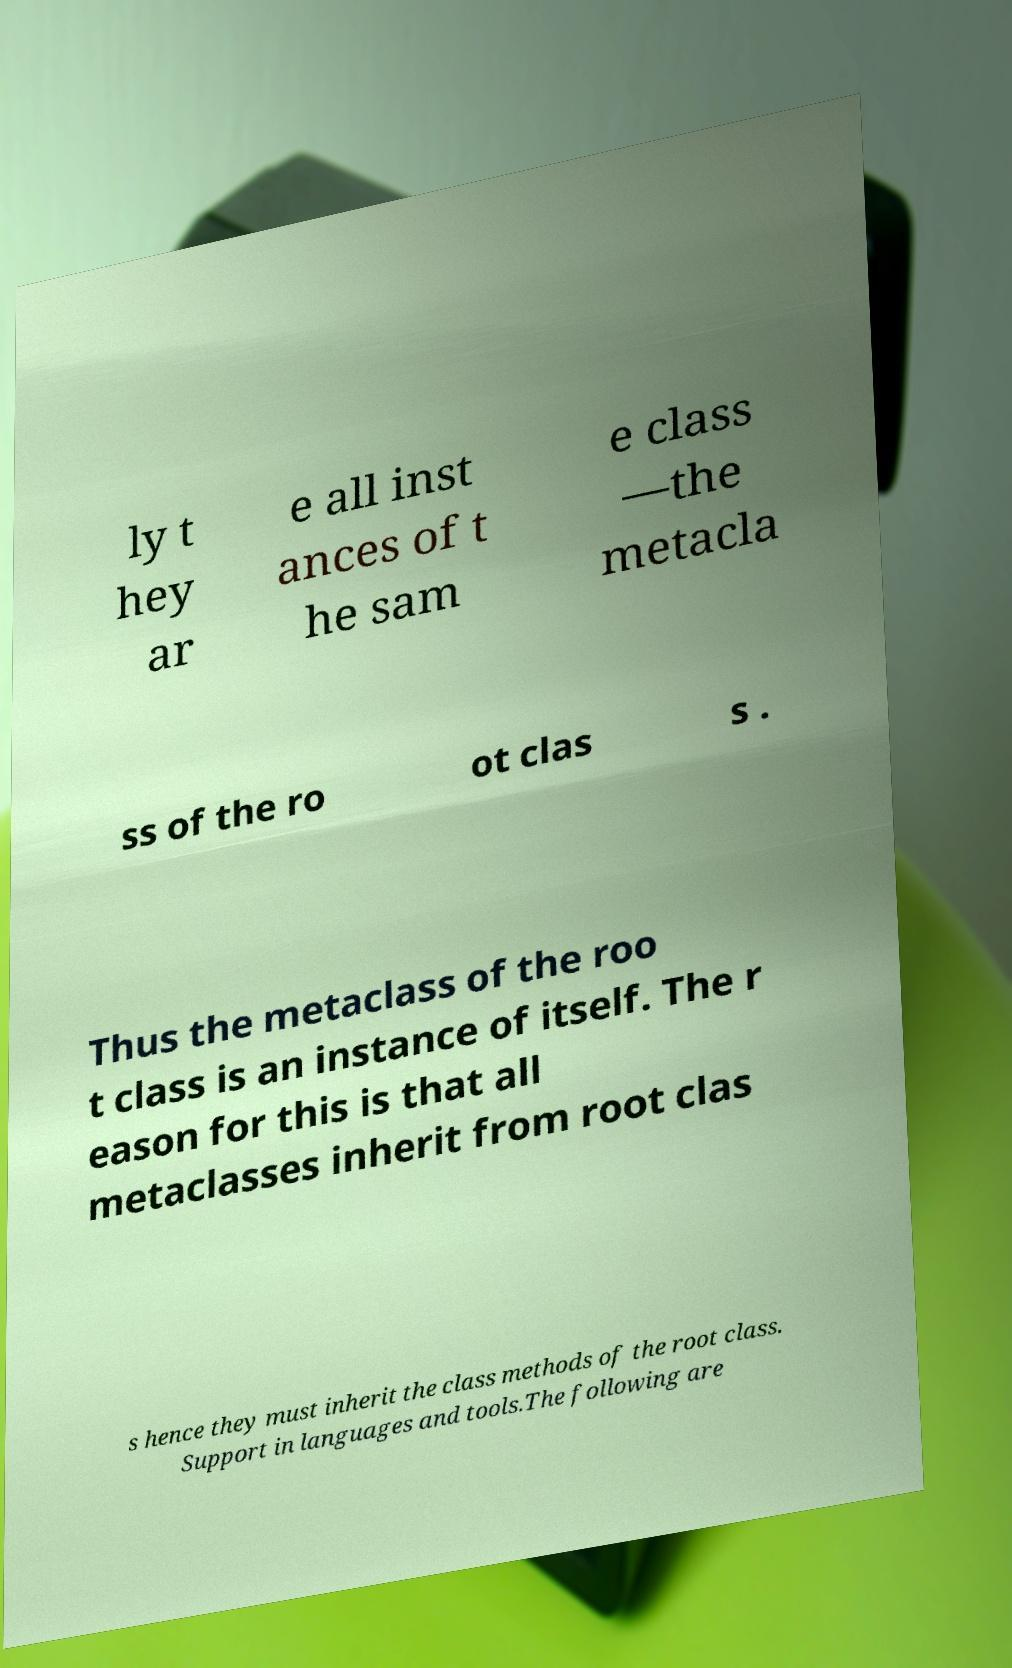Could you extract and type out the text from this image? ly t hey ar e all inst ances of t he sam e class —the metacla ss of the ro ot clas s . Thus the metaclass of the roo t class is an instance of itself. The r eason for this is that all metaclasses inherit from root clas s hence they must inherit the class methods of the root class. Support in languages and tools.The following are 